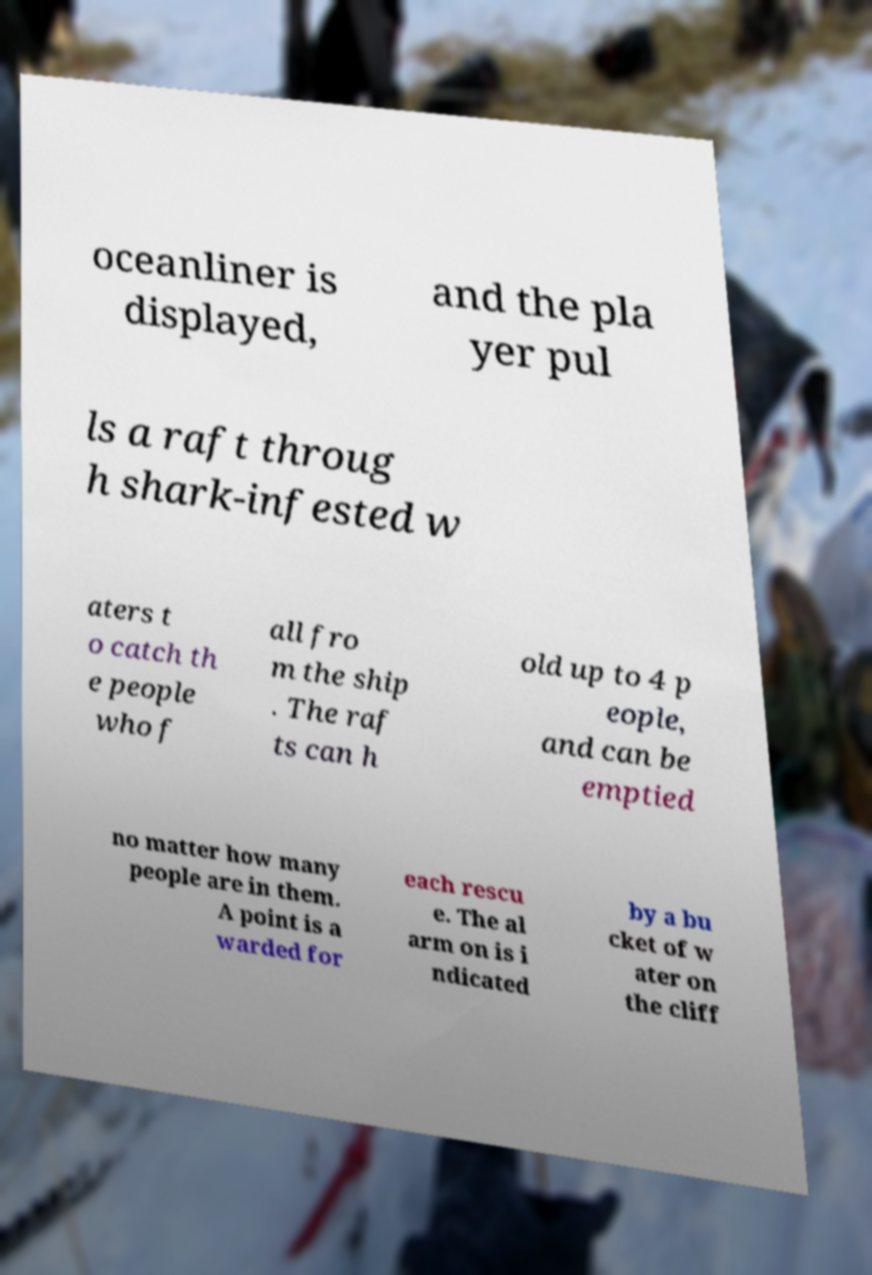There's text embedded in this image that I need extracted. Can you transcribe it verbatim? oceanliner is displayed, and the pla yer pul ls a raft throug h shark-infested w aters t o catch th e people who f all fro m the ship . The raf ts can h old up to 4 p eople, and can be emptied no matter how many people are in them. A point is a warded for each rescu e. The al arm on is i ndicated by a bu cket of w ater on the cliff 